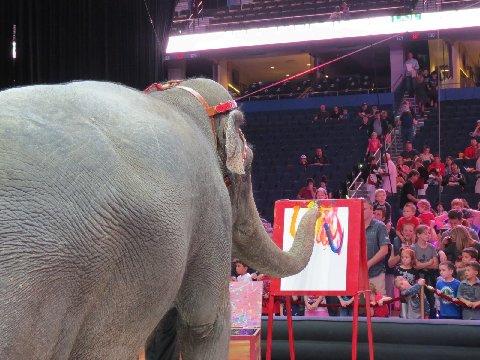Is the elephant drawing?
Quick response, please. Yes. What color is this elephant?
Write a very short answer. Gray. What color is the easel?
Concise answer only. Red. What is around the elephant's neck?
Concise answer only. Collar. 